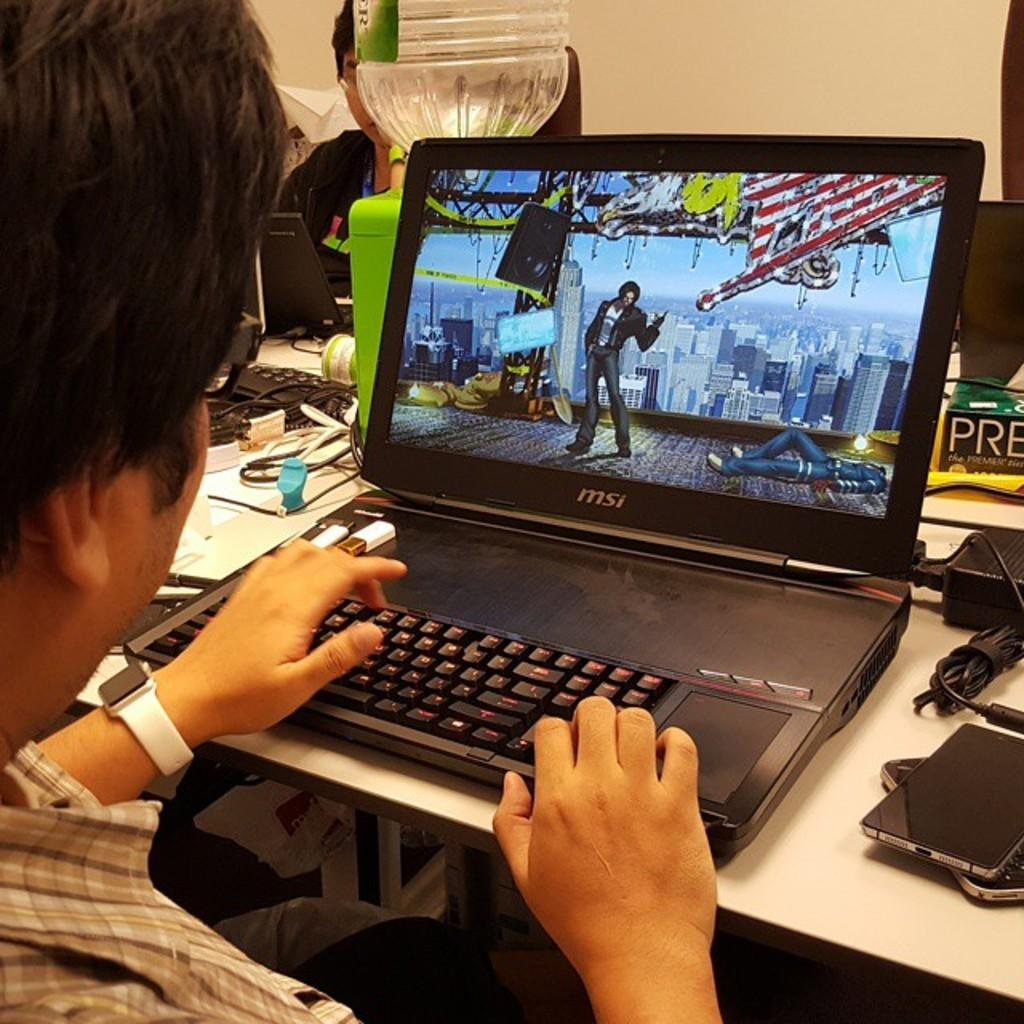<image>
Describe the image concisely. A man on a Msi brand laptop looking at a game character 